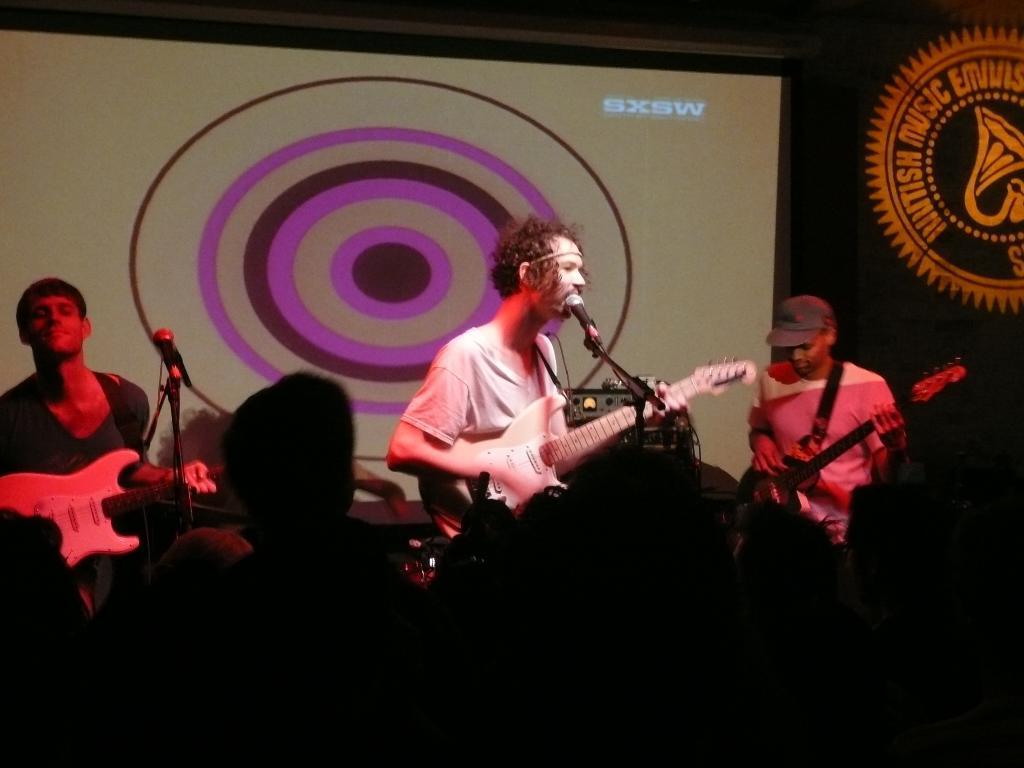How would you summarize this image in a sentence or two? On the left there is man with guitar in his hand. There is a mic. In the center there is a man singing a song. On the right there is a man wearing a cap. There is a crowd listening to the music. 